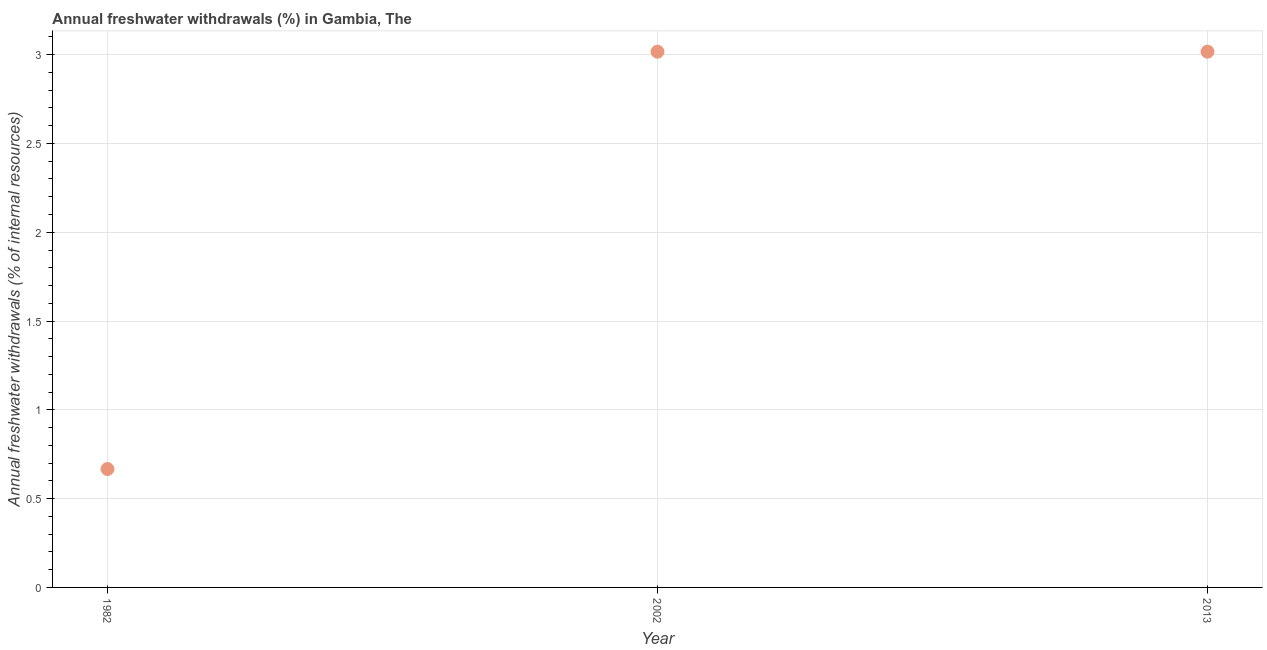What is the annual freshwater withdrawals in 2002?
Offer a very short reply. 3.02. Across all years, what is the maximum annual freshwater withdrawals?
Your response must be concise. 3.02. Across all years, what is the minimum annual freshwater withdrawals?
Provide a short and direct response. 0.67. In which year was the annual freshwater withdrawals maximum?
Ensure brevity in your answer.  2002. In which year was the annual freshwater withdrawals minimum?
Keep it short and to the point. 1982. What is the sum of the annual freshwater withdrawals?
Your answer should be very brief. 6.7. What is the difference between the annual freshwater withdrawals in 1982 and 2002?
Provide a short and direct response. -2.35. What is the average annual freshwater withdrawals per year?
Provide a short and direct response. 2.23. What is the median annual freshwater withdrawals?
Make the answer very short. 3.02. In how many years, is the annual freshwater withdrawals greater than 2 %?
Make the answer very short. 2. What is the ratio of the annual freshwater withdrawals in 1982 to that in 2013?
Provide a short and direct response. 0.22. Is the difference between the annual freshwater withdrawals in 1982 and 2013 greater than the difference between any two years?
Provide a succinct answer. Yes. What is the difference between the highest and the second highest annual freshwater withdrawals?
Your answer should be very brief. 0. Is the sum of the annual freshwater withdrawals in 1982 and 2013 greater than the maximum annual freshwater withdrawals across all years?
Keep it short and to the point. Yes. What is the difference between the highest and the lowest annual freshwater withdrawals?
Your answer should be compact. 2.35. In how many years, is the annual freshwater withdrawals greater than the average annual freshwater withdrawals taken over all years?
Your answer should be very brief. 2. Does the annual freshwater withdrawals monotonically increase over the years?
Your answer should be compact. No. How many dotlines are there?
Give a very brief answer. 1. How many years are there in the graph?
Your response must be concise. 3. Does the graph contain any zero values?
Offer a terse response. No. Does the graph contain grids?
Give a very brief answer. Yes. What is the title of the graph?
Make the answer very short. Annual freshwater withdrawals (%) in Gambia, The. What is the label or title of the X-axis?
Provide a succinct answer. Year. What is the label or title of the Y-axis?
Your answer should be compact. Annual freshwater withdrawals (% of internal resources). What is the Annual freshwater withdrawals (% of internal resources) in 1982?
Provide a succinct answer. 0.67. What is the Annual freshwater withdrawals (% of internal resources) in 2002?
Keep it short and to the point. 3.02. What is the Annual freshwater withdrawals (% of internal resources) in 2013?
Offer a terse response. 3.02. What is the difference between the Annual freshwater withdrawals (% of internal resources) in 1982 and 2002?
Give a very brief answer. -2.35. What is the difference between the Annual freshwater withdrawals (% of internal resources) in 1982 and 2013?
Offer a very short reply. -2.35. What is the difference between the Annual freshwater withdrawals (% of internal resources) in 2002 and 2013?
Ensure brevity in your answer.  0. What is the ratio of the Annual freshwater withdrawals (% of internal resources) in 1982 to that in 2002?
Offer a terse response. 0.22. What is the ratio of the Annual freshwater withdrawals (% of internal resources) in 1982 to that in 2013?
Ensure brevity in your answer.  0.22. 